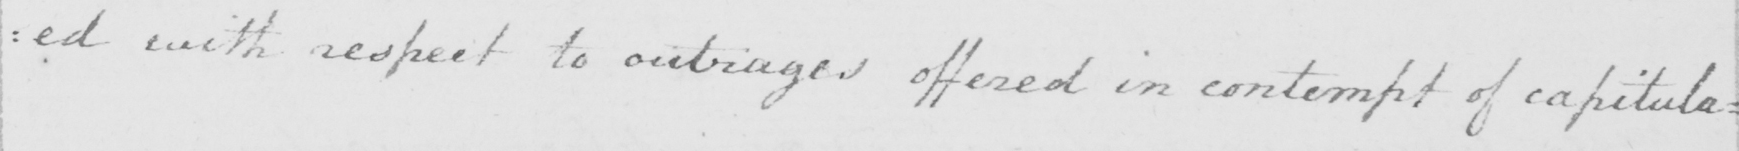Please provide the text content of this handwritten line. : ed with respect to outrages offered in contempt of capitula= 